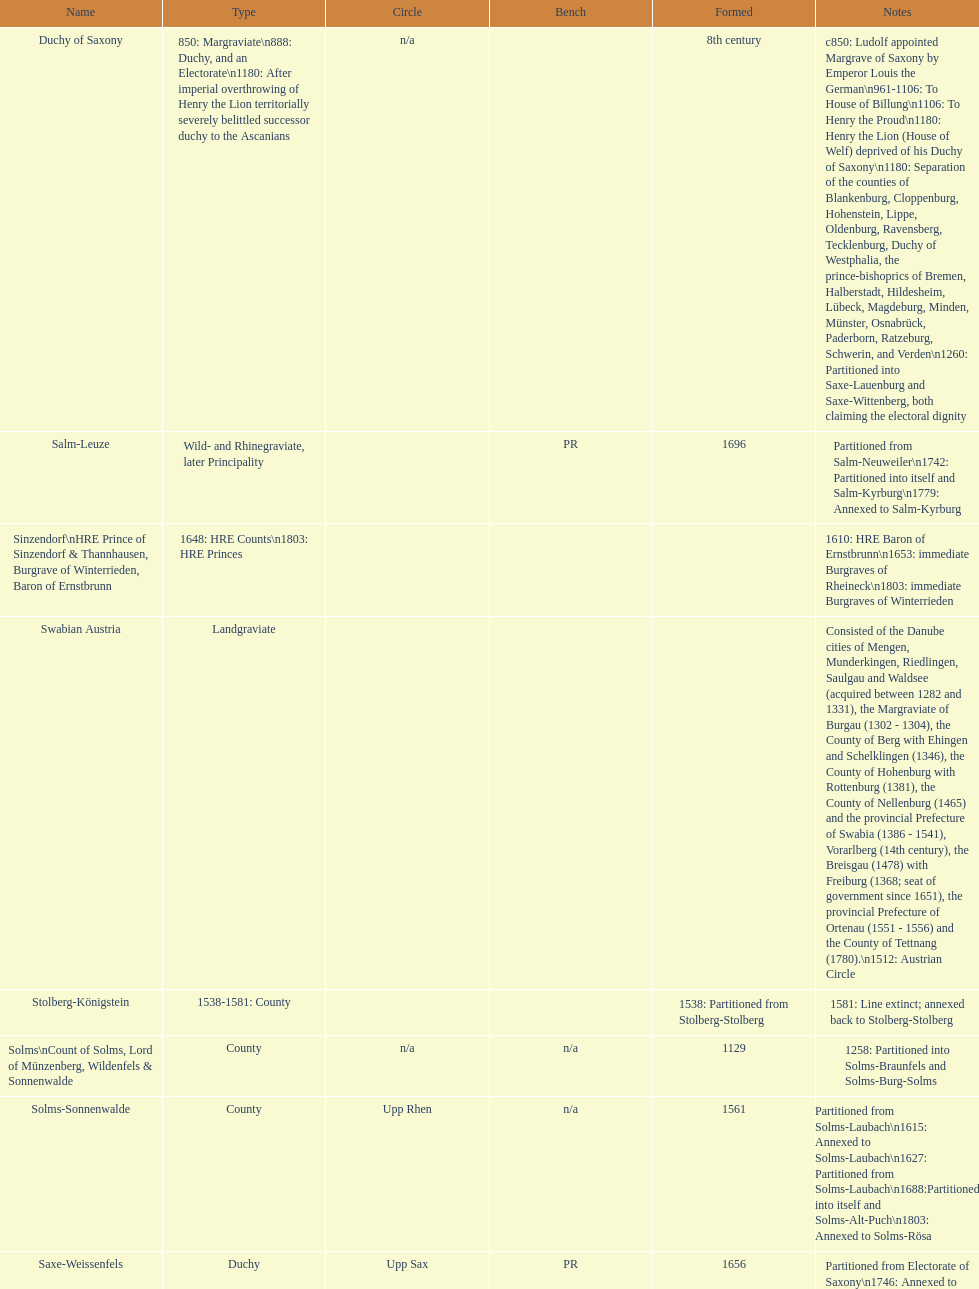How many states were of the same kind as stühlingen? 3. 